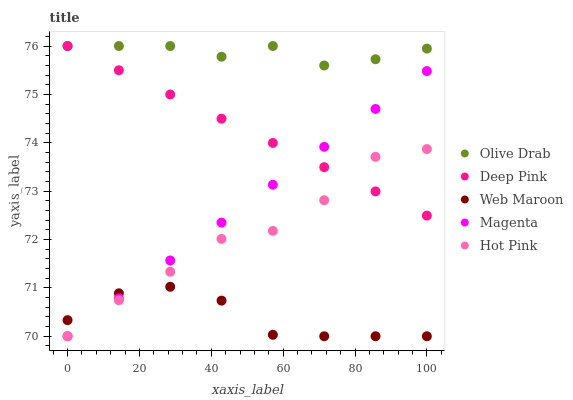Does Web Maroon have the minimum area under the curve?
Answer yes or no. Yes. Does Olive Drab have the maximum area under the curve?
Answer yes or no. Yes. Does Deep Pink have the minimum area under the curve?
Answer yes or no. No. Does Deep Pink have the maximum area under the curve?
Answer yes or no. No. Is Deep Pink the smoothest?
Answer yes or no. Yes. Is Hot Pink the roughest?
Answer yes or no. Yes. Is Web Maroon the smoothest?
Answer yes or no. No. Is Web Maroon the roughest?
Answer yes or no. No. Does Magenta have the lowest value?
Answer yes or no. Yes. Does Deep Pink have the lowest value?
Answer yes or no. No. Does Olive Drab have the highest value?
Answer yes or no. Yes. Does Web Maroon have the highest value?
Answer yes or no. No. Is Hot Pink less than Olive Drab?
Answer yes or no. Yes. Is Olive Drab greater than Web Maroon?
Answer yes or no. Yes. Does Web Maroon intersect Magenta?
Answer yes or no. Yes. Is Web Maroon less than Magenta?
Answer yes or no. No. Is Web Maroon greater than Magenta?
Answer yes or no. No. Does Hot Pink intersect Olive Drab?
Answer yes or no. No. 